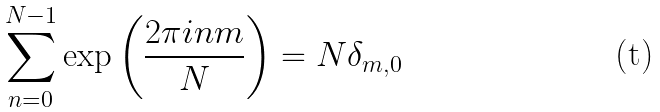<formula> <loc_0><loc_0><loc_500><loc_500>\sum _ { n = 0 } ^ { N - 1 } \exp \left ( \frac { 2 \pi i n m } { N } \right ) = N \delta _ { m , 0 }</formula> 